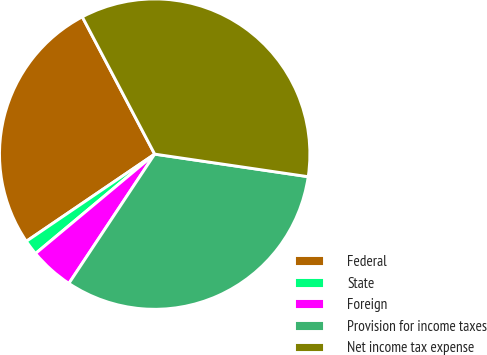Convert chart. <chart><loc_0><loc_0><loc_500><loc_500><pie_chart><fcel>Federal<fcel>State<fcel>Foreign<fcel>Provision for income taxes<fcel>Net income tax expense<nl><fcel>26.77%<fcel>1.57%<fcel>4.61%<fcel>32.0%<fcel>35.05%<nl></chart> 